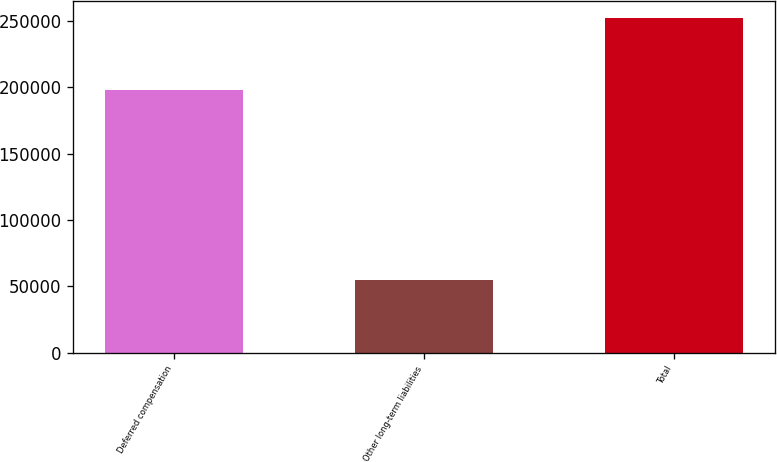Convert chart. <chart><loc_0><loc_0><loc_500><loc_500><bar_chart><fcel>Deferred compensation<fcel>Other long-term liabilities<fcel>Total<nl><fcel>197542<fcel>54485<fcel>252027<nl></chart> 